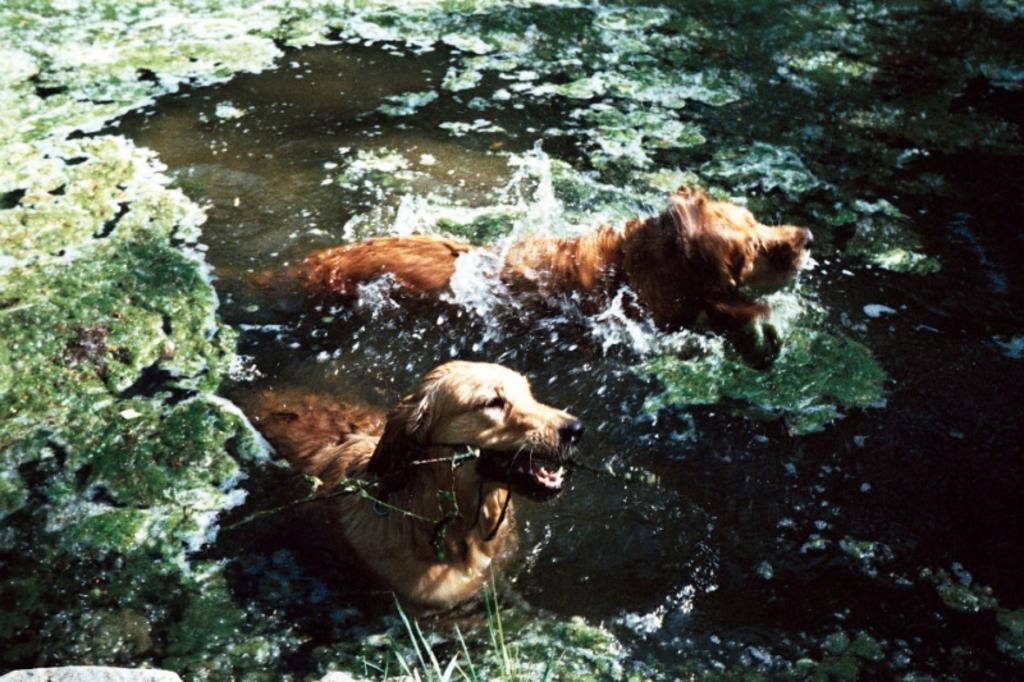How many dogs are in the image? There are two dogs in the image. What are the dogs doing in the image? The dogs are swimming in the water. Can you describe the water in the image? The water might be in a pond. What is present on the left side of the image? There is algae on the left side of the image. What can be seen in the background of the image? There is algae visible in the background of the image. Can you see any icicles hanging from the trees in the image? There are no trees visible in the image, so it is not possible to see any icicles hanging from them. 